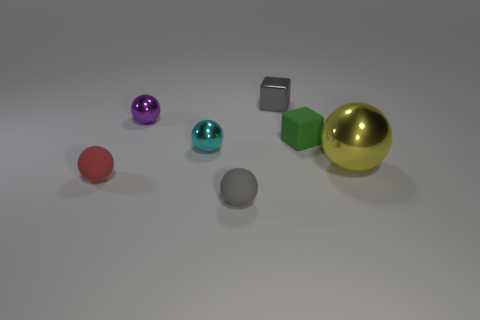Subtract all tiny cyan metal spheres. How many spheres are left? 4 Add 2 big rubber blocks. How many objects exist? 9 Subtract all purple spheres. How many spheres are left? 4 Subtract all balls. How many objects are left? 2 Subtract all purple balls. Subtract all blue blocks. How many balls are left? 4 Add 2 shiny balls. How many shiny balls are left? 5 Add 2 gray balls. How many gray balls exist? 3 Subtract 1 cyan balls. How many objects are left? 6 Subtract all small purple rubber spheres. Subtract all small green cubes. How many objects are left? 6 